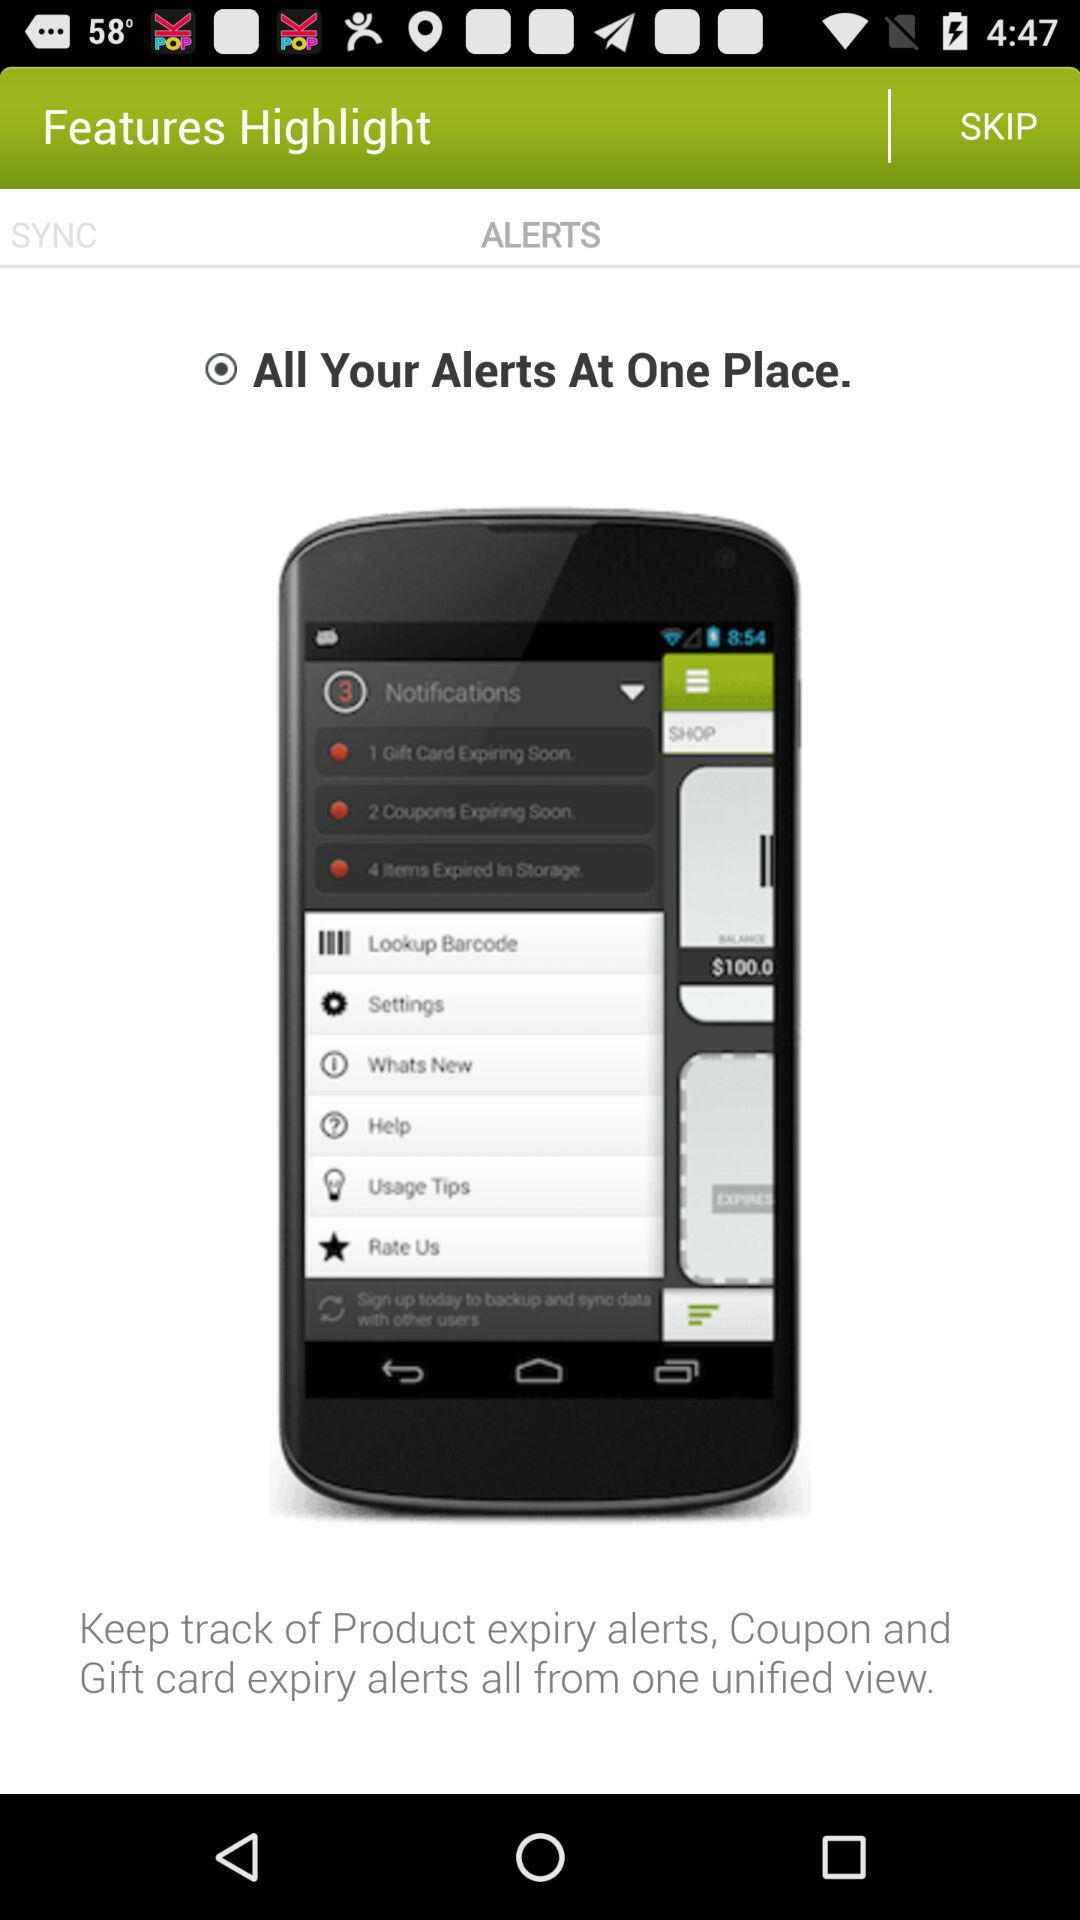What is the status of the "All Your Alerts At One Place"? The status is on. 